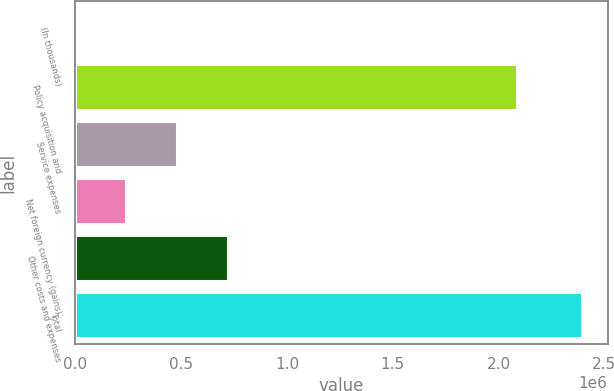Convert chart to OTSL. <chart><loc_0><loc_0><loc_500><loc_500><bar_chart><fcel>(In thousands)<fcel>Policy acquisition and<fcel>Service expenses<fcel>Net foreign currency (gains)<fcel>Other costs and expenses<fcel>Total<nl><fcel>2016<fcel>2.0892e+06<fcel>480737<fcel>241376<fcel>720097<fcel>2.39562e+06<nl></chart> 